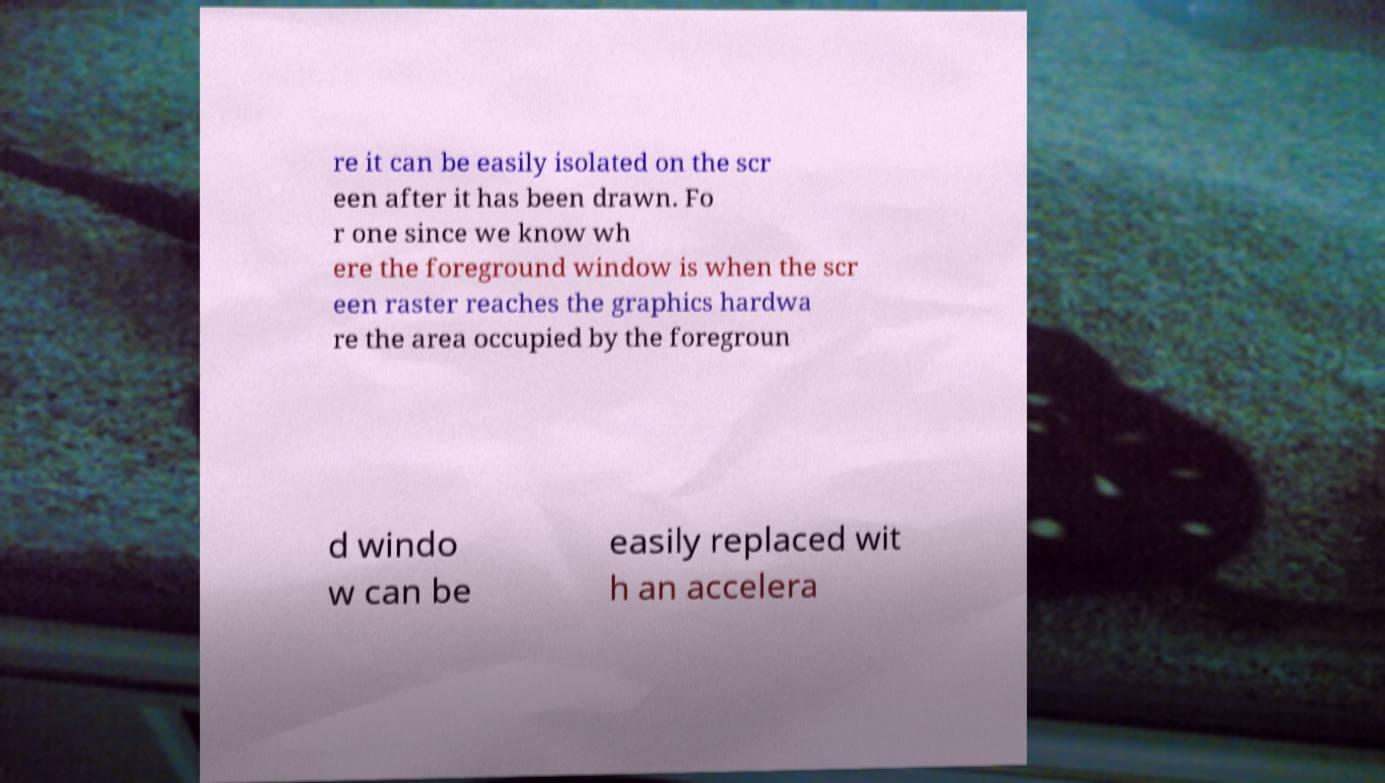There's text embedded in this image that I need extracted. Can you transcribe it verbatim? re it can be easily isolated on the scr een after it has been drawn. Fo r one since we know wh ere the foreground window is when the scr een raster reaches the graphics hardwa re the area occupied by the foregroun d windo w can be easily replaced wit h an accelera 